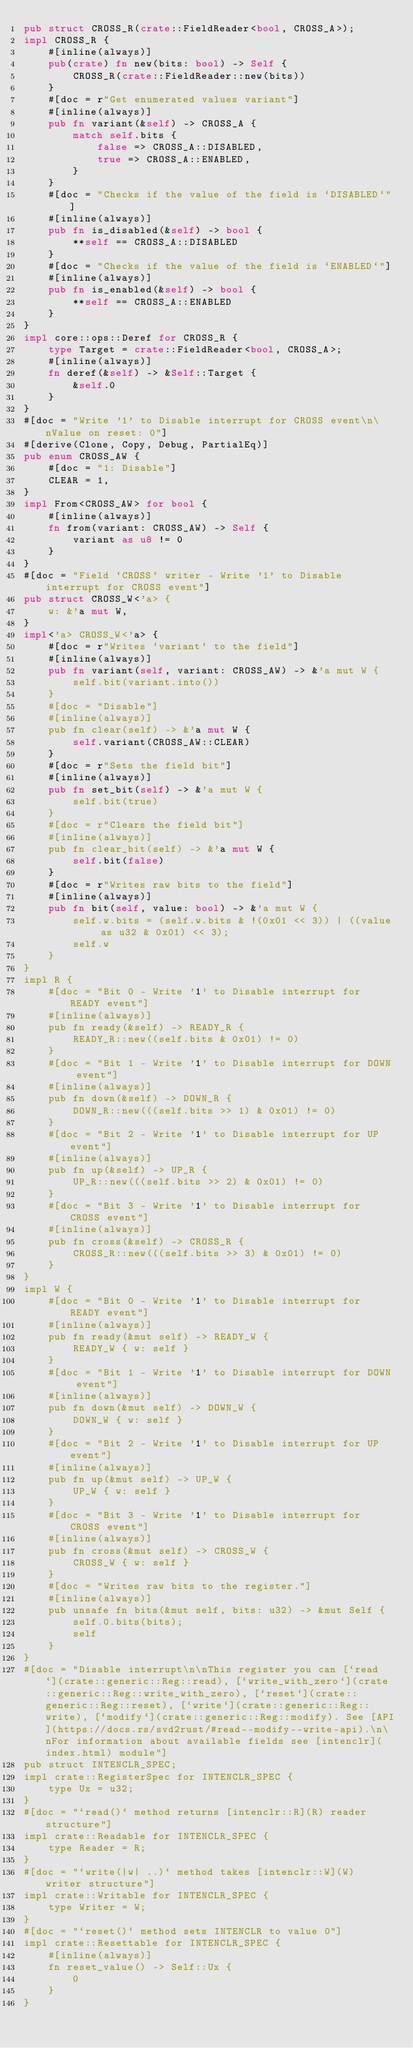<code> <loc_0><loc_0><loc_500><loc_500><_Rust_>pub struct CROSS_R(crate::FieldReader<bool, CROSS_A>);
impl CROSS_R {
    #[inline(always)]
    pub(crate) fn new(bits: bool) -> Self {
        CROSS_R(crate::FieldReader::new(bits))
    }
    #[doc = r"Get enumerated values variant"]
    #[inline(always)]
    pub fn variant(&self) -> CROSS_A {
        match self.bits {
            false => CROSS_A::DISABLED,
            true => CROSS_A::ENABLED,
        }
    }
    #[doc = "Checks if the value of the field is `DISABLED`"]
    #[inline(always)]
    pub fn is_disabled(&self) -> bool {
        **self == CROSS_A::DISABLED
    }
    #[doc = "Checks if the value of the field is `ENABLED`"]
    #[inline(always)]
    pub fn is_enabled(&self) -> bool {
        **self == CROSS_A::ENABLED
    }
}
impl core::ops::Deref for CROSS_R {
    type Target = crate::FieldReader<bool, CROSS_A>;
    #[inline(always)]
    fn deref(&self) -> &Self::Target {
        &self.0
    }
}
#[doc = "Write '1' to Disable interrupt for CROSS event\n\nValue on reset: 0"]
#[derive(Clone, Copy, Debug, PartialEq)]
pub enum CROSS_AW {
    #[doc = "1: Disable"]
    CLEAR = 1,
}
impl From<CROSS_AW> for bool {
    #[inline(always)]
    fn from(variant: CROSS_AW) -> Self {
        variant as u8 != 0
    }
}
#[doc = "Field `CROSS` writer - Write '1' to Disable interrupt for CROSS event"]
pub struct CROSS_W<'a> {
    w: &'a mut W,
}
impl<'a> CROSS_W<'a> {
    #[doc = r"Writes `variant` to the field"]
    #[inline(always)]
    pub fn variant(self, variant: CROSS_AW) -> &'a mut W {
        self.bit(variant.into())
    }
    #[doc = "Disable"]
    #[inline(always)]
    pub fn clear(self) -> &'a mut W {
        self.variant(CROSS_AW::CLEAR)
    }
    #[doc = r"Sets the field bit"]
    #[inline(always)]
    pub fn set_bit(self) -> &'a mut W {
        self.bit(true)
    }
    #[doc = r"Clears the field bit"]
    #[inline(always)]
    pub fn clear_bit(self) -> &'a mut W {
        self.bit(false)
    }
    #[doc = r"Writes raw bits to the field"]
    #[inline(always)]
    pub fn bit(self, value: bool) -> &'a mut W {
        self.w.bits = (self.w.bits & !(0x01 << 3)) | ((value as u32 & 0x01) << 3);
        self.w
    }
}
impl R {
    #[doc = "Bit 0 - Write '1' to Disable interrupt for READY event"]
    #[inline(always)]
    pub fn ready(&self) -> READY_R {
        READY_R::new((self.bits & 0x01) != 0)
    }
    #[doc = "Bit 1 - Write '1' to Disable interrupt for DOWN event"]
    #[inline(always)]
    pub fn down(&self) -> DOWN_R {
        DOWN_R::new(((self.bits >> 1) & 0x01) != 0)
    }
    #[doc = "Bit 2 - Write '1' to Disable interrupt for UP event"]
    #[inline(always)]
    pub fn up(&self) -> UP_R {
        UP_R::new(((self.bits >> 2) & 0x01) != 0)
    }
    #[doc = "Bit 3 - Write '1' to Disable interrupt for CROSS event"]
    #[inline(always)]
    pub fn cross(&self) -> CROSS_R {
        CROSS_R::new(((self.bits >> 3) & 0x01) != 0)
    }
}
impl W {
    #[doc = "Bit 0 - Write '1' to Disable interrupt for READY event"]
    #[inline(always)]
    pub fn ready(&mut self) -> READY_W {
        READY_W { w: self }
    }
    #[doc = "Bit 1 - Write '1' to Disable interrupt for DOWN event"]
    #[inline(always)]
    pub fn down(&mut self) -> DOWN_W {
        DOWN_W { w: self }
    }
    #[doc = "Bit 2 - Write '1' to Disable interrupt for UP event"]
    #[inline(always)]
    pub fn up(&mut self) -> UP_W {
        UP_W { w: self }
    }
    #[doc = "Bit 3 - Write '1' to Disable interrupt for CROSS event"]
    #[inline(always)]
    pub fn cross(&mut self) -> CROSS_W {
        CROSS_W { w: self }
    }
    #[doc = "Writes raw bits to the register."]
    #[inline(always)]
    pub unsafe fn bits(&mut self, bits: u32) -> &mut Self {
        self.0.bits(bits);
        self
    }
}
#[doc = "Disable interrupt\n\nThis register you can [`read`](crate::generic::Reg::read), [`write_with_zero`](crate::generic::Reg::write_with_zero), [`reset`](crate::generic::Reg::reset), [`write`](crate::generic::Reg::write), [`modify`](crate::generic::Reg::modify). See [API](https://docs.rs/svd2rust/#read--modify--write-api).\n\nFor information about available fields see [intenclr](index.html) module"]
pub struct INTENCLR_SPEC;
impl crate::RegisterSpec for INTENCLR_SPEC {
    type Ux = u32;
}
#[doc = "`read()` method returns [intenclr::R](R) reader structure"]
impl crate::Readable for INTENCLR_SPEC {
    type Reader = R;
}
#[doc = "`write(|w| ..)` method takes [intenclr::W](W) writer structure"]
impl crate::Writable for INTENCLR_SPEC {
    type Writer = W;
}
#[doc = "`reset()` method sets INTENCLR to value 0"]
impl crate::Resettable for INTENCLR_SPEC {
    #[inline(always)]
    fn reset_value() -> Self::Ux {
        0
    }
}
</code> 